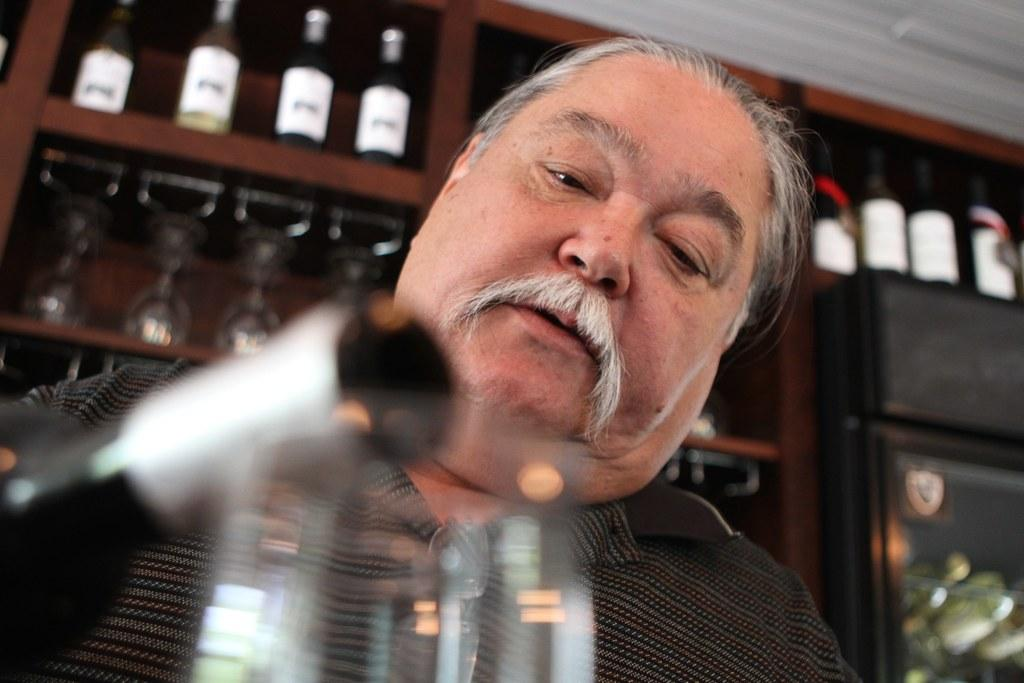Who is present in the image? There is a man in the image. What objects can be seen in the image? There is a bottle and a glass in the image. What is visible in the background of the image? Wine glasses and bottles in racks are visible in the background of the image. What type of paste is being applied to the hot cloud in the image? There is no paste, hot object, or cloud present in the image. 